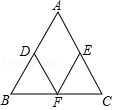In triangle ABC, where AB = AC, the midpoints of edges AB, AC, and BC are denoted as D, E, and F, respectively. If CE has a length of 'x' units, determine the perimeter of quadrilateral ADFE in terms of 'x'. Considering triangle ABC with AB = AC, the midpoints D, E, and F create smaller triangles within the larger one that are all similar to triangle ABC. These smaller triangles are also congruent because ABC is an isosceles triangle. As E is the midpoint of AC, AE = EC = x. Since D and F are midpoints as well, AD = DB and CF = FB, making AD and CF equal to x (half of AB and AC). Consequently, DF = x. Since AD = AE and DF = EF (as F is the midpoint of BC), the perimeter of quadrilateral ADFE is the sum of AD, DF, FE, and EA, which are all x. Therefore, we have 4x as the perimeter of ADFE. This approach visualizes the geometric relationships in the triangle to find the solution, making the process more informative and engaging. 